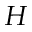<formula> <loc_0><loc_0><loc_500><loc_500>H</formula> 